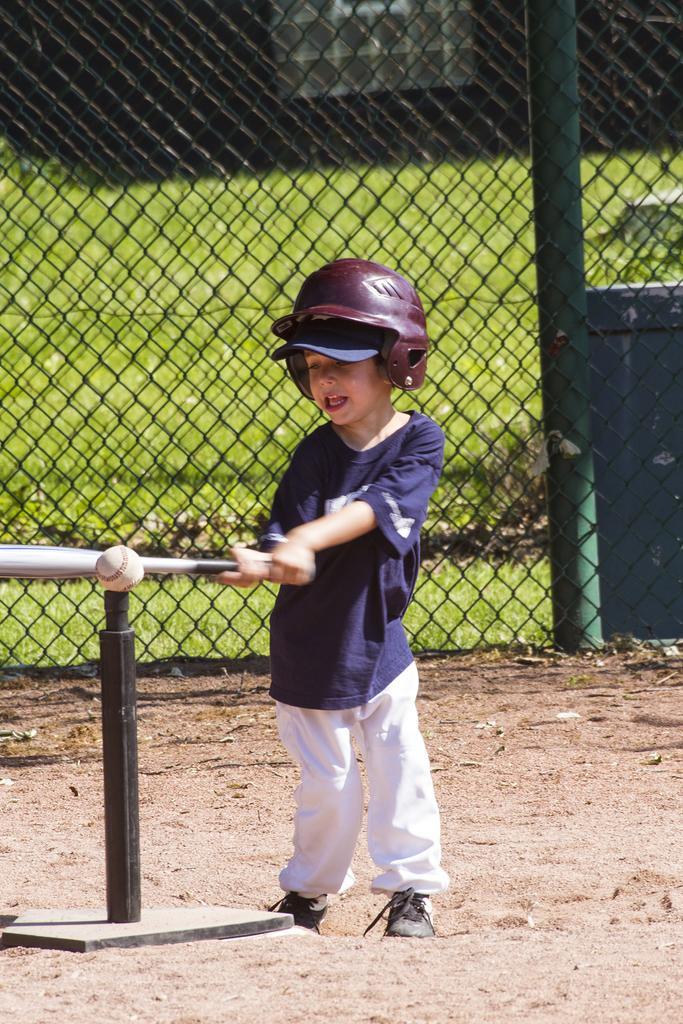In one or two sentences, can you explain what this image depicts? In the image there is a boy with a helmet with hand holding a bat in his hand. In front of the bat there is a ball. Below the bat there is a pole. Behind them there is fencing. Behind the fencing it is blurry and also there is a house. 